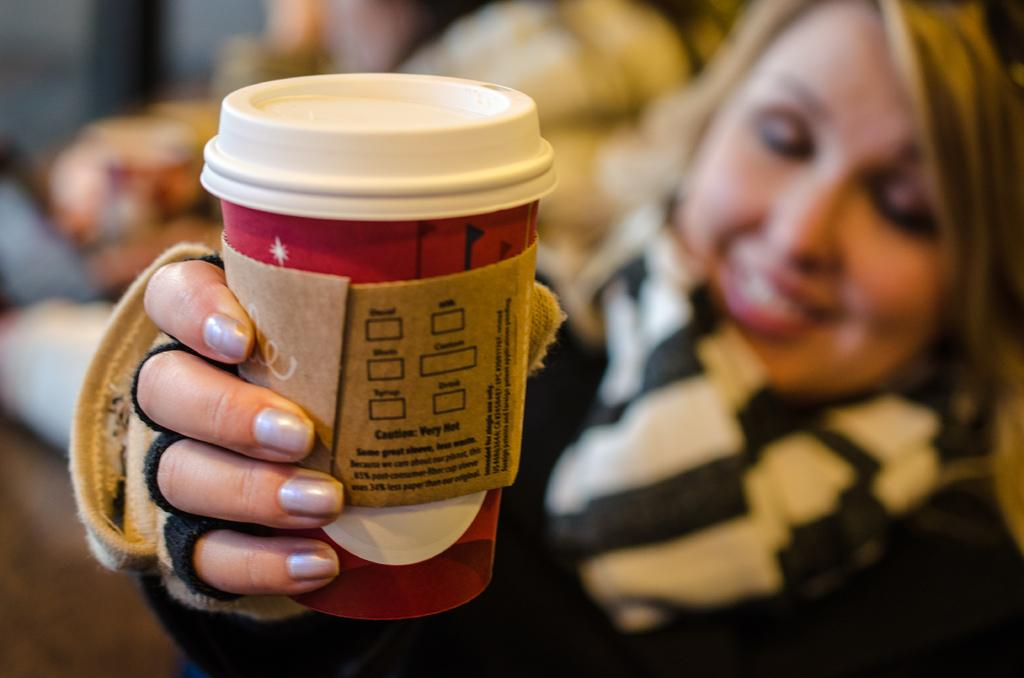Who is the main subject in the image? There is a person in the center of the image. What is the person wearing? The person is wearing a different costume. What is the person's facial expression? The person is smiling. What is the person holding in the image? The person is holding an object. Can you describe the background of the image? The background of the image is blurred. Is the person sitting on a chair in the image? There is no chair present in the image. What type of spy equipment can be seen in the person's hand? There is no spy equipment visible in the image; the person is holding an object, but its purpose is not specified. 